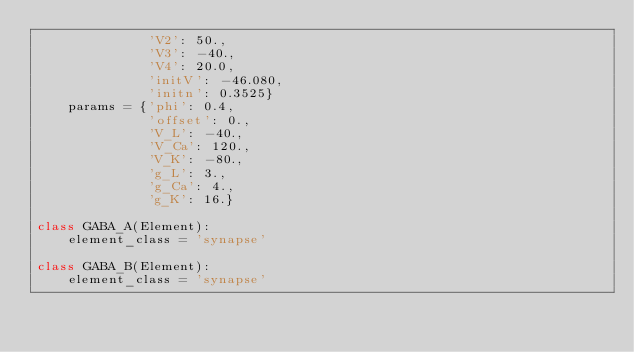<code> <loc_0><loc_0><loc_500><loc_500><_Python_>              'V2': 50.,
              'V3': -40.,
              'V4': 20.0,
              'initV': -46.080,
              'initn': 0.3525}
    params = {'phi': 0.4,
              'offset': 0., 
              'V_L': -40., 
              'V_Ca': 120., 
              'V_K': -80., 
              'g_L': 3., 
              'g_Ca': 4., 
              'g_K': 16.}

class GABA_A(Element):
    element_class = 'synapse'

class GABA_B(Element):
    element_class = 'synapse'
</code> 